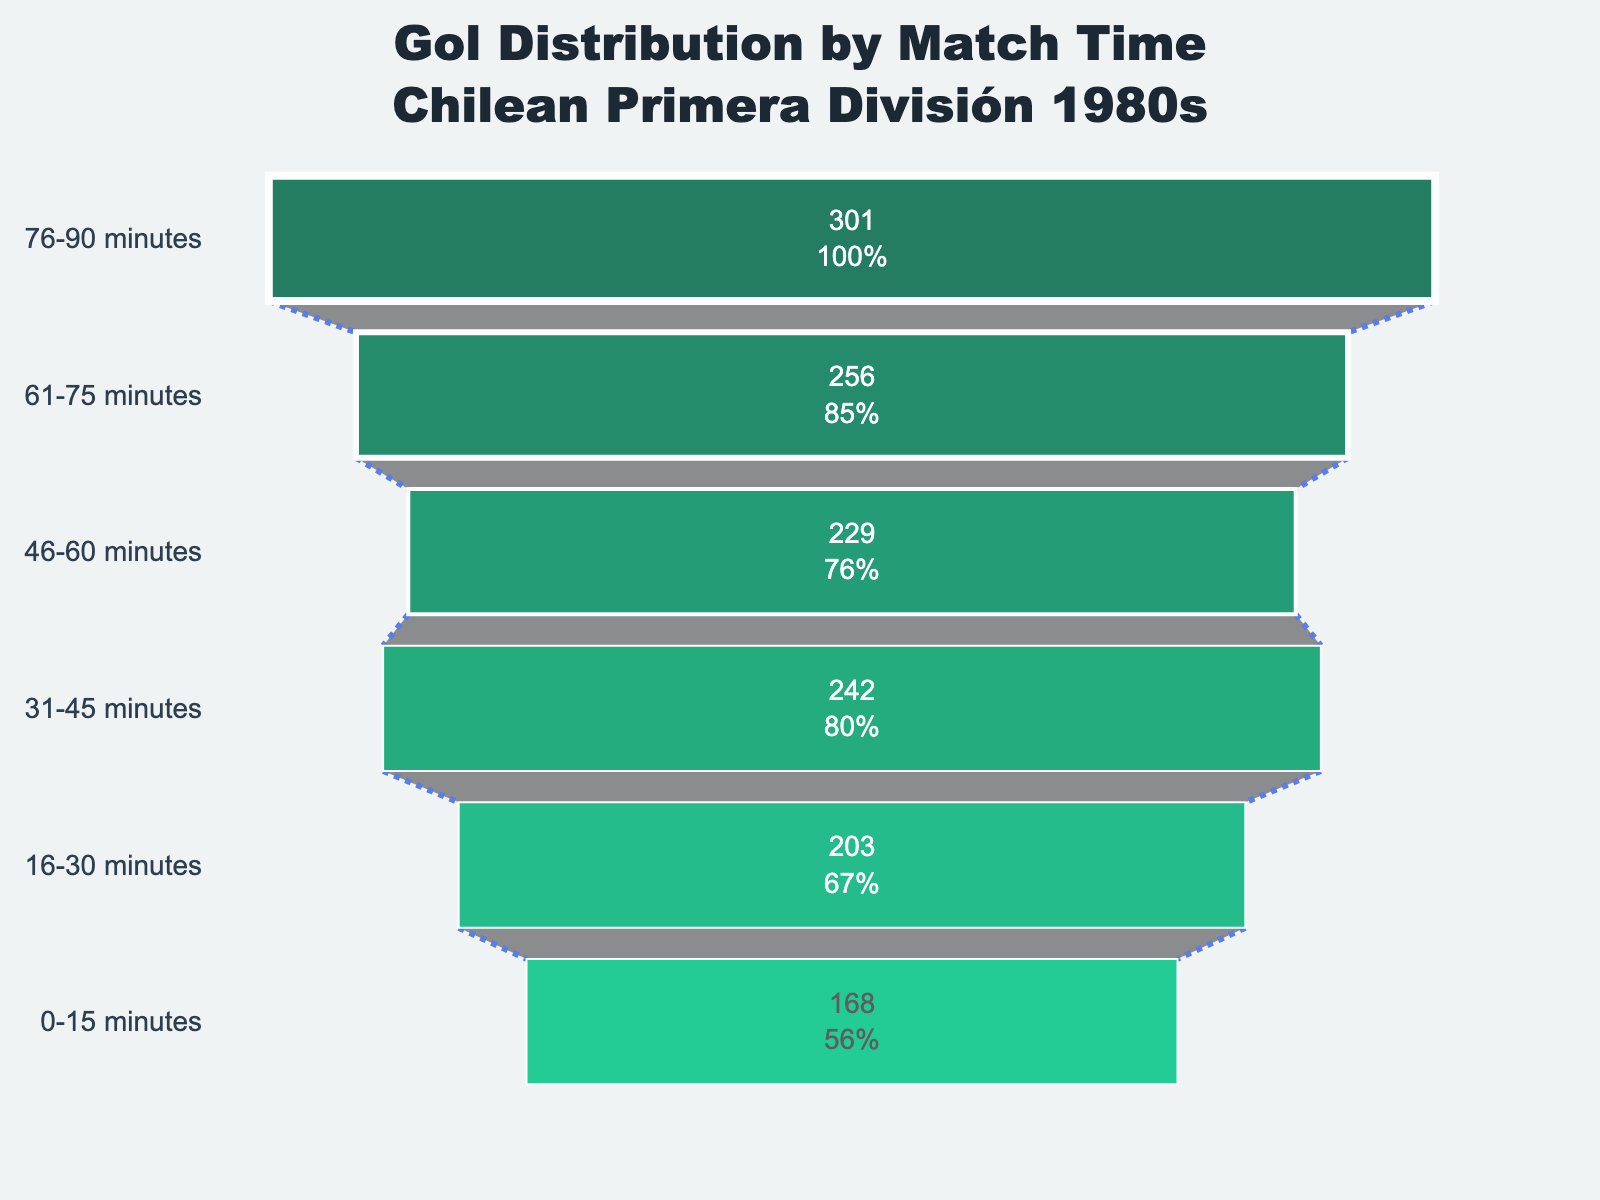What is the title of the figure? The title is placed prominently at the top of the figure and provides a summary of the data being visualized.
Answer: "Gol Distribution by Match Time<br>Chilean Primera División 1980s" How many match time intervals are shown in the chart? The figure displays six different match time intervals as distinct horizontal segments in the funnel chart.
Answer: 6 Which match time interval had the highest number of goals scored? The interval with the highest number of goals will have the widest funnel portion on the chart, located at the bottom since the intervals are reversed.
Answer: 76-90 minutes What is the percentage of goals scored in the 46-60 minutes interval relative to the total? Find the numerical value for goals in this interval and then find the percentage provided inside the segment.
Answer: 229 goals, X% Which interval shows a greater number of goals: 16-30 minutes or 31-45 minutes? Compare the length of the funnel sections for these two intervals; the longer one represents more goals.
Answer: 31-45 minutes How many more goals were scored in the 61-75 minutes interval compared to the 0-15 minutes interval? Subtract the number of goals in the 0-15 minutes from the 61-75 minutes interval: 256 - 168.
Answer: 88 goals What percentage of total goals were scored during the last 15 minutes of the match? The percentage is indicated inside the funnel segment for the 76-90 minutes interval. The last segment in the funnel graph visually represents this data.
Answer: X% Which color is used for the segment representing the 31-45 minutes interval? Identify the specific shade applied to the funnel segment corresponding to the 31-45 minutes interval, which can be found by examining the sequential order.
Answer: Green What's the sum of goals scored in the first half of the match? Add the number of goals from the 0-15, 16-30, and 31-45 minutes intervals: 168 + 203 + 242.
Answer: 613 goals How does the width of the connector lines change from top to bottom in the chart? Observe the lines connecting the segments of the funnel; the width decreases progressively going downward.
Answer: Decreases 